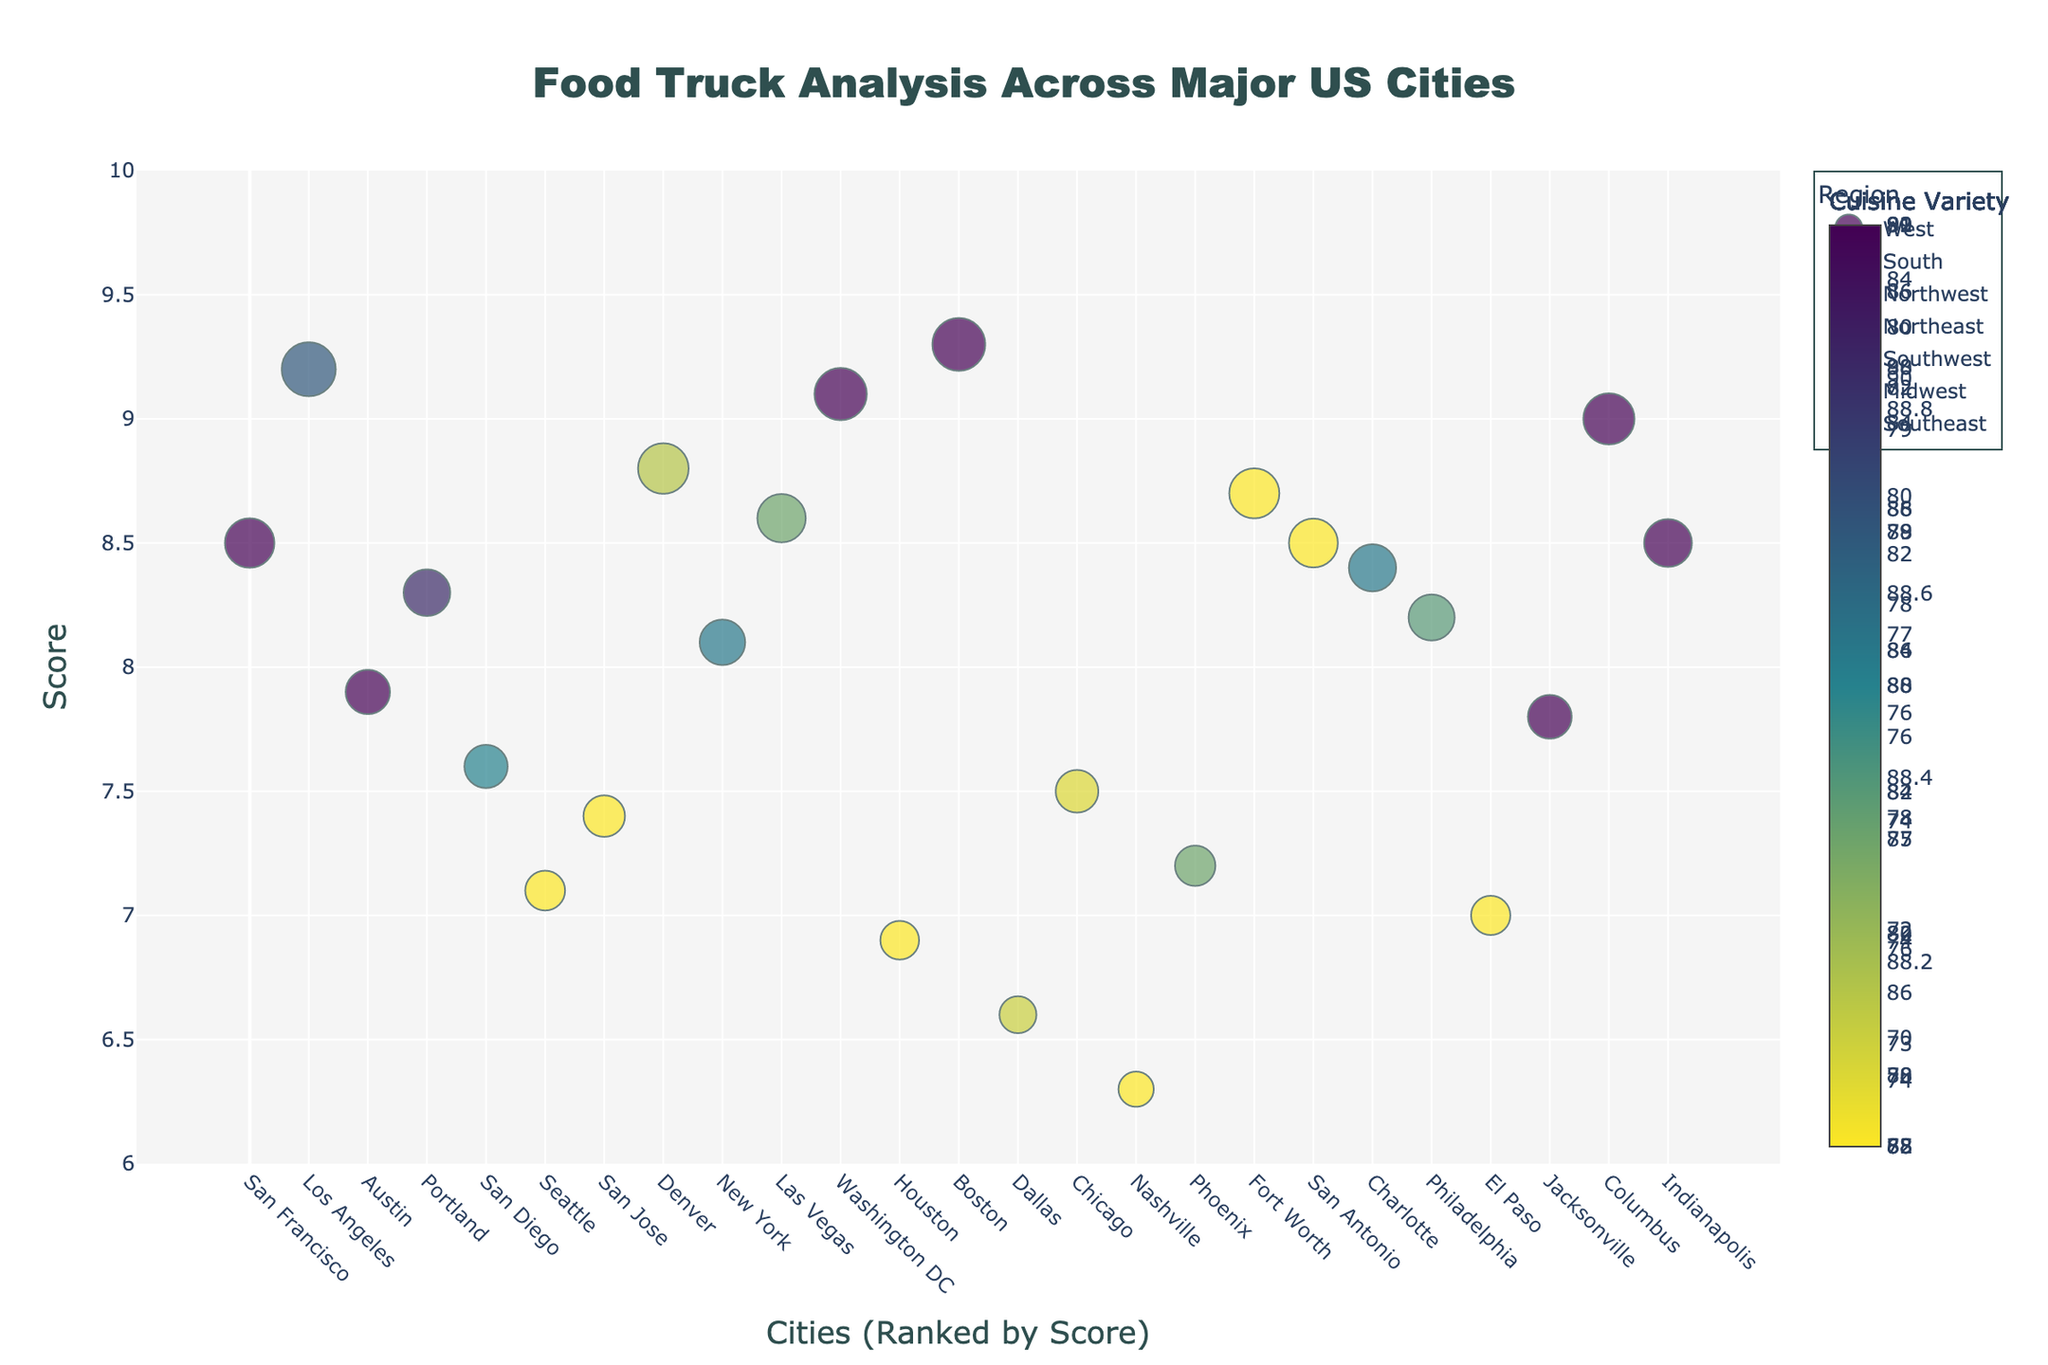Which city has the highest food truck score? By examining the y-axis and finding the data point with the highest value, which represents the score, we see that the city at the highest point is identified in the hover template.
Answer: San Francisco How does the food truck density of Austin compare to that of San Diego? Look at the marker sizes for both Austin and San Diego. Austin's marker size represents a density value of 92, while San Diego's marker size is related to a density of 89.
Answer: Austin has a higher food truck density than San Diego What is the range of scores for cities in the Northeast? Identify the cities in the Northeast (New York, Philadelphia, Washington DC, Boston) and compare their y-axis values. New York (8.5), Philadelphia (7.1), Washington DC (8.4), and Boston (8.2) give a range from 7.1 to 8.5.
Answer: 7.1 to 8.5 Which region has the city with the lowest cuisine variety? Observe the color scale and the hover text to find the city with the lowest cuisine variety. Indianapolis in the Midwest has a cuisine variety score of 68.
Answer: Midwest Is there a city with equal food truck density and cuisine variety scores? Check the hover template for each data point to find any city where both values are the same. It's a detailed check across multiple data points.
Answer: No How many cities in the West region have a score above 8.5? Identify cities in the West region (Los Angeles, San Diego, San Jose, San Francisco, Denver) and count those with scores above 8.5 (Los Angeles, San Diego, San Francisco).
Answer: 3 What is the difference in food truck density between Chicago and Columbus? Refer to the hover text for both cities. Chicago has a density of 78, and Columbus has a density of 65. Subtract the smaller value from the larger one.
Answer: 13 Which city in the Southeast has the highest score? List the Southeastern cities (Jacksonville, Charlotte, Nashville) and compare their scores: Jacksonville (6.9), Charlotte (7.2), Nashville (7.8).
Answer: Nashville What is the average cuisine variety for cities in the South region? Identify the cuisine variety values for southern cities (Houston: 88, San Antonio: 77, Dallas: 84, Austin: 90, Fort Worth: 78) and calculate the average. (88 + 77 + 84 + 90 + 78) / 5 = 83.4
Answer: 83.4 